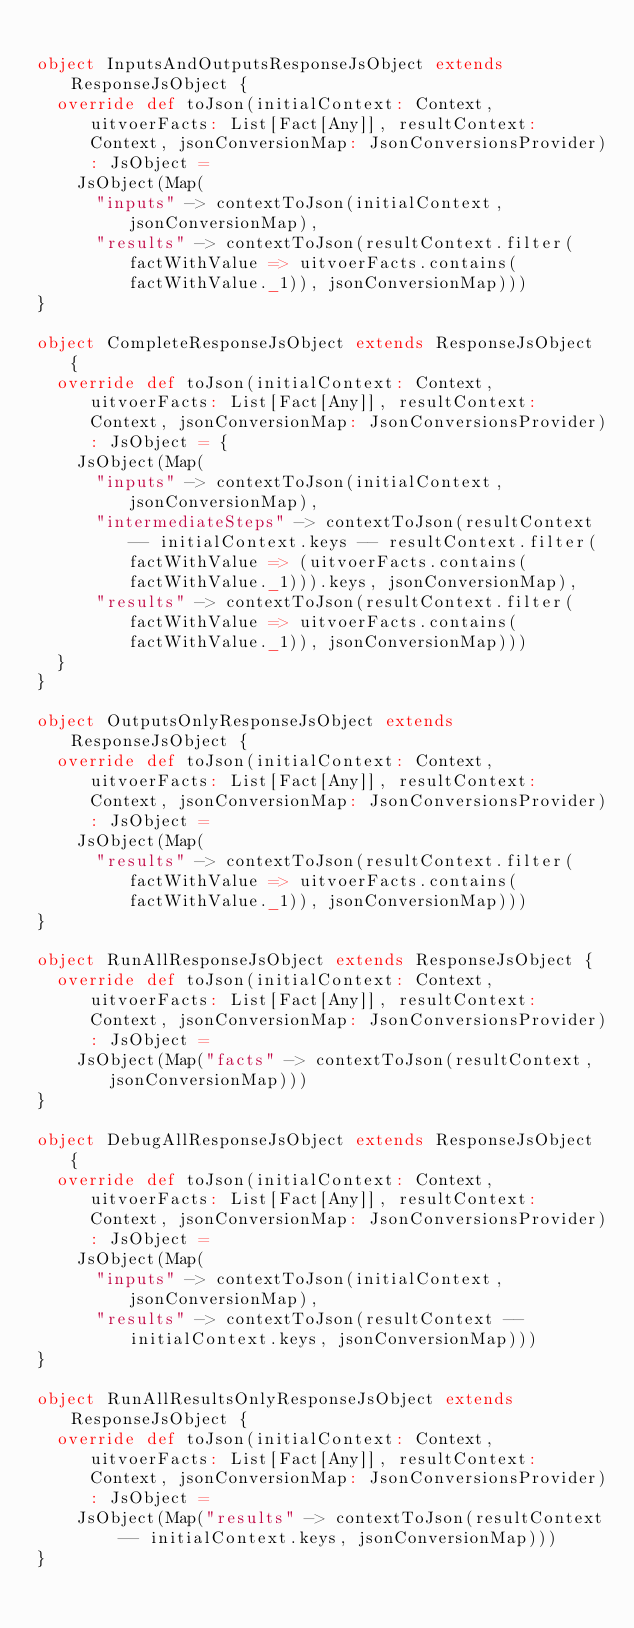<code> <loc_0><loc_0><loc_500><loc_500><_Scala_>
object InputsAndOutputsResponseJsObject extends ResponseJsObject {
  override def toJson(initialContext: Context, uitvoerFacts: List[Fact[Any]], resultContext: Context, jsonConversionMap: JsonConversionsProvider): JsObject =
    JsObject(Map(
      "inputs" -> contextToJson(initialContext, jsonConversionMap),
      "results" -> contextToJson(resultContext.filter(factWithValue => uitvoerFacts.contains(factWithValue._1)), jsonConversionMap)))
}

object CompleteResponseJsObject extends ResponseJsObject {
  override def toJson(initialContext: Context, uitvoerFacts: List[Fact[Any]], resultContext: Context, jsonConversionMap: JsonConversionsProvider): JsObject = {
    JsObject(Map(
      "inputs" -> contextToJson(initialContext, jsonConversionMap),
      "intermediateSteps" -> contextToJson(resultContext -- initialContext.keys -- resultContext.filter(factWithValue => (uitvoerFacts.contains(factWithValue._1))).keys, jsonConversionMap),
      "results" -> contextToJson(resultContext.filter(factWithValue => uitvoerFacts.contains(factWithValue._1)), jsonConversionMap)))
  }
}

object OutputsOnlyResponseJsObject extends ResponseJsObject {
  override def toJson(initialContext: Context, uitvoerFacts: List[Fact[Any]], resultContext: Context, jsonConversionMap: JsonConversionsProvider): JsObject =
    JsObject(Map(
      "results" -> contextToJson(resultContext.filter(factWithValue => uitvoerFacts.contains(factWithValue._1)), jsonConversionMap)))
}

object RunAllResponseJsObject extends ResponseJsObject {
  override def toJson(initialContext: Context, uitvoerFacts: List[Fact[Any]], resultContext: Context, jsonConversionMap: JsonConversionsProvider): JsObject =
    JsObject(Map("facts" -> contextToJson(resultContext, jsonConversionMap)))
}

object DebugAllResponseJsObject extends ResponseJsObject {
  override def toJson(initialContext: Context, uitvoerFacts: List[Fact[Any]], resultContext: Context, jsonConversionMap: JsonConversionsProvider): JsObject =
    JsObject(Map(
      "inputs" -> contextToJson(initialContext, jsonConversionMap),
      "results" -> contextToJson(resultContext -- initialContext.keys, jsonConversionMap)))
}

object RunAllResultsOnlyResponseJsObject extends ResponseJsObject {
  override def toJson(initialContext: Context, uitvoerFacts: List[Fact[Any]], resultContext: Context, jsonConversionMap: JsonConversionsProvider): JsObject =
    JsObject(Map("results" -> contextToJson(resultContext -- initialContext.keys, jsonConversionMap)))
}

</code> 